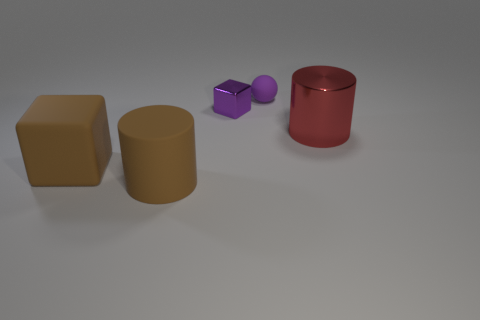What material is the purple object that is the same size as the shiny cube?
Give a very brief answer. Rubber. Are there any large metal cylinders behind the small object that is to the left of the small purple ball?
Provide a succinct answer. No. What number of other objects are there of the same color as the big metal thing?
Your response must be concise. 0. What size is the ball?
Make the answer very short. Small. Is there a red cylinder?
Your response must be concise. Yes. Is the number of red metal things that are left of the red shiny object greater than the number of red cylinders left of the tiny rubber object?
Offer a terse response. No. What material is the object that is on the right side of the purple metal block and in front of the small purple metallic object?
Give a very brief answer. Metal. Is the shape of the red metallic object the same as the purple matte object?
Offer a terse response. No. Is there anything else that is the same size as the purple matte thing?
Ensure brevity in your answer.  Yes. What number of small balls are left of the small shiny block?
Make the answer very short. 0. 